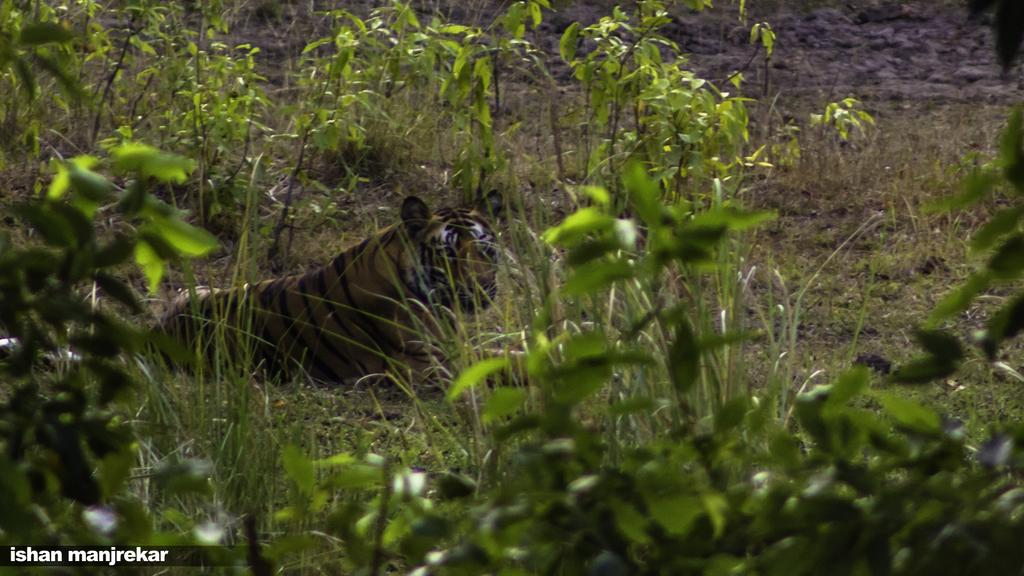What animal is the main subject of the image? There is a tiger in the image. Where is the tiger located? The tiger is sitting on the grassland. What can be seen in the grassland besides the tiger? There are plants in the grassland. What is present in the bottom left corner of the image? There is some text in the bottom left corner of the image. What type of pot is the tiger using to lift the bit in the image? There is no pot, lifting, or bit present in the image; it features a tiger sitting on the grassland. 